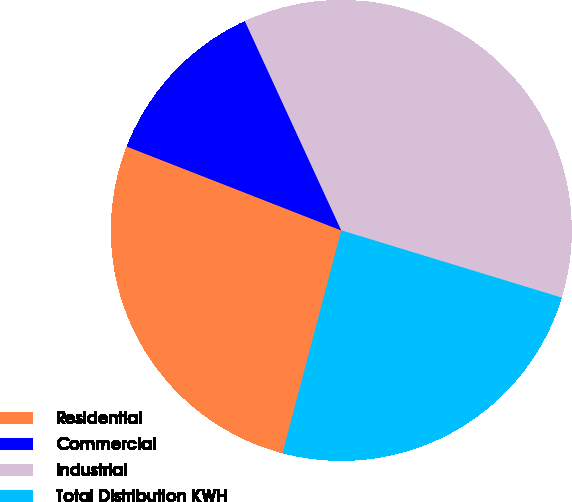Convert chart. <chart><loc_0><loc_0><loc_500><loc_500><pie_chart><fcel>Residential<fcel>Commercial<fcel>Industrial<fcel>Total Distribution KWH<nl><fcel>26.83%<fcel>12.2%<fcel>36.59%<fcel>24.39%<nl></chart> 